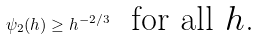Convert formula to latex. <formula><loc_0><loc_0><loc_500><loc_500>\psi _ { 2 } ( h ) \geq h ^ { - 2 / 3 } \ \text { for all $h$.}</formula> 